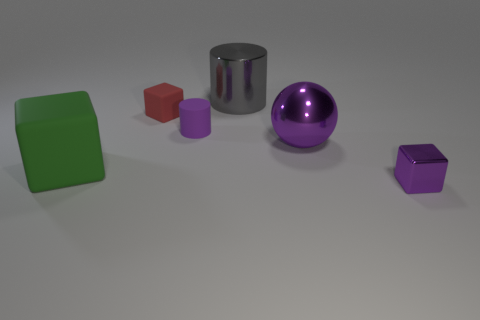Are the small cube that is to the left of the purple ball and the ball made of the same material?
Keep it short and to the point. No. What shape is the shiny thing behind the red matte cube?
Keep it short and to the point. Cylinder. How many gray cylinders are the same size as the green block?
Provide a short and direct response. 1. The shiny cube is what size?
Your answer should be compact. Small. What number of big purple metal balls are to the left of the small red matte block?
Give a very brief answer. 0. What shape is the other tiny object that is made of the same material as the small red thing?
Provide a short and direct response. Cylinder. Are there fewer gray metallic cylinders left of the tiny red cube than objects right of the small purple cylinder?
Ensure brevity in your answer.  Yes. Is the number of large cyan metallic blocks greater than the number of red matte cubes?
Give a very brief answer. No. What is the tiny purple cube made of?
Your response must be concise. Metal. There is a cube right of the big gray object; what color is it?
Your answer should be compact. Purple. 